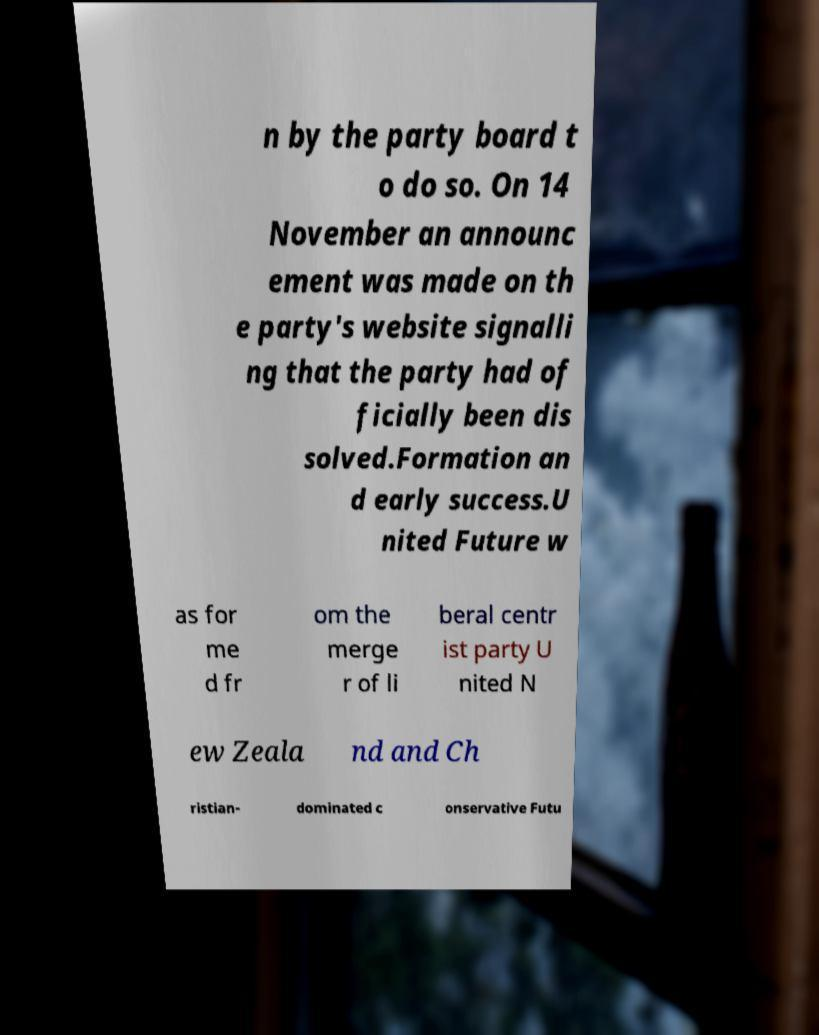There's text embedded in this image that I need extracted. Can you transcribe it verbatim? n by the party board t o do so. On 14 November an announc ement was made on th e party's website signalli ng that the party had of ficially been dis solved.Formation an d early success.U nited Future w as for me d fr om the merge r of li beral centr ist party U nited N ew Zeala nd and Ch ristian- dominated c onservative Futu 